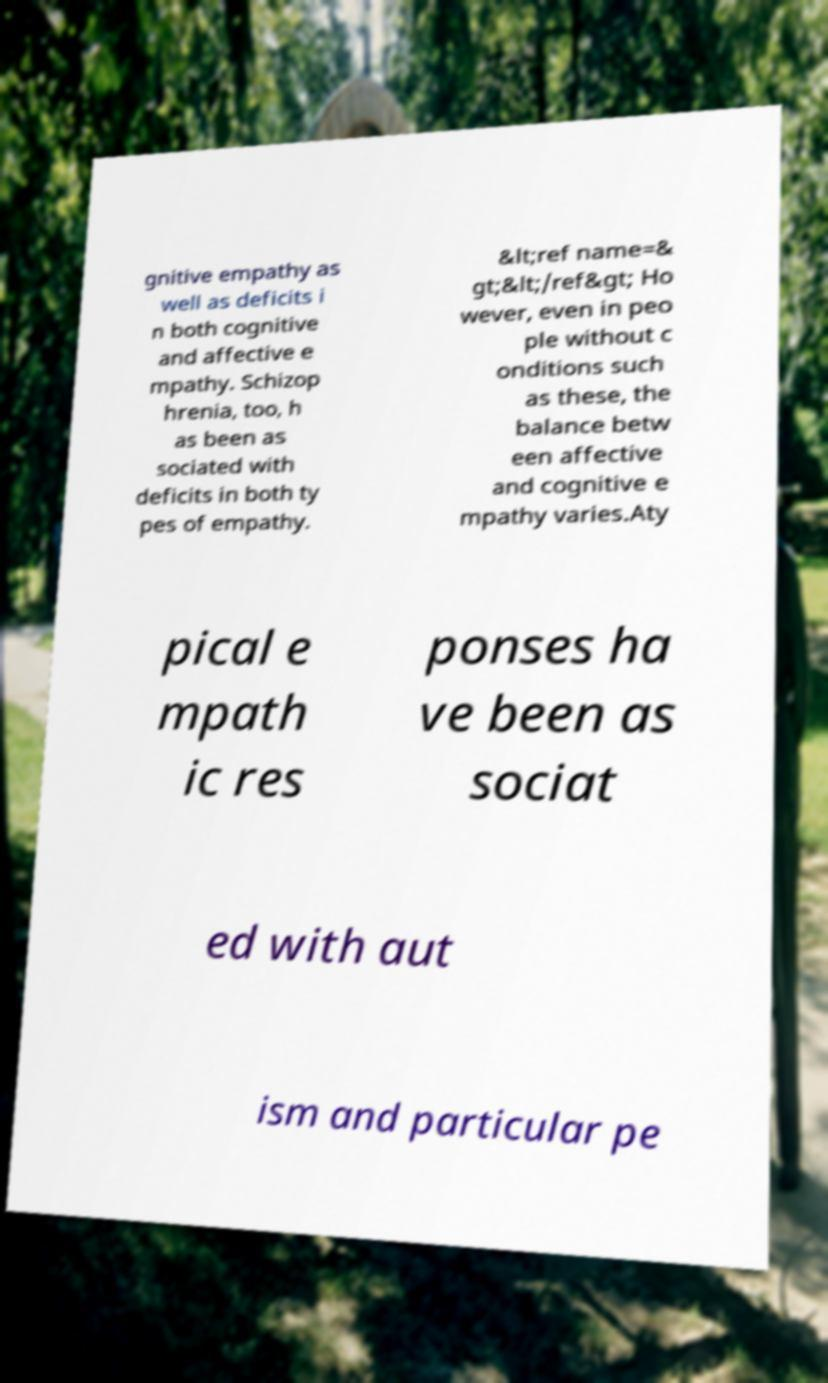What messages or text are displayed in this image? I need them in a readable, typed format. gnitive empathy as well as deficits i n both cognitive and affective e mpathy. Schizop hrenia, too, h as been as sociated with deficits in both ty pes of empathy. &lt;ref name=& gt;&lt;/ref&gt; Ho wever, even in peo ple without c onditions such as these, the balance betw een affective and cognitive e mpathy varies.Aty pical e mpath ic res ponses ha ve been as sociat ed with aut ism and particular pe 